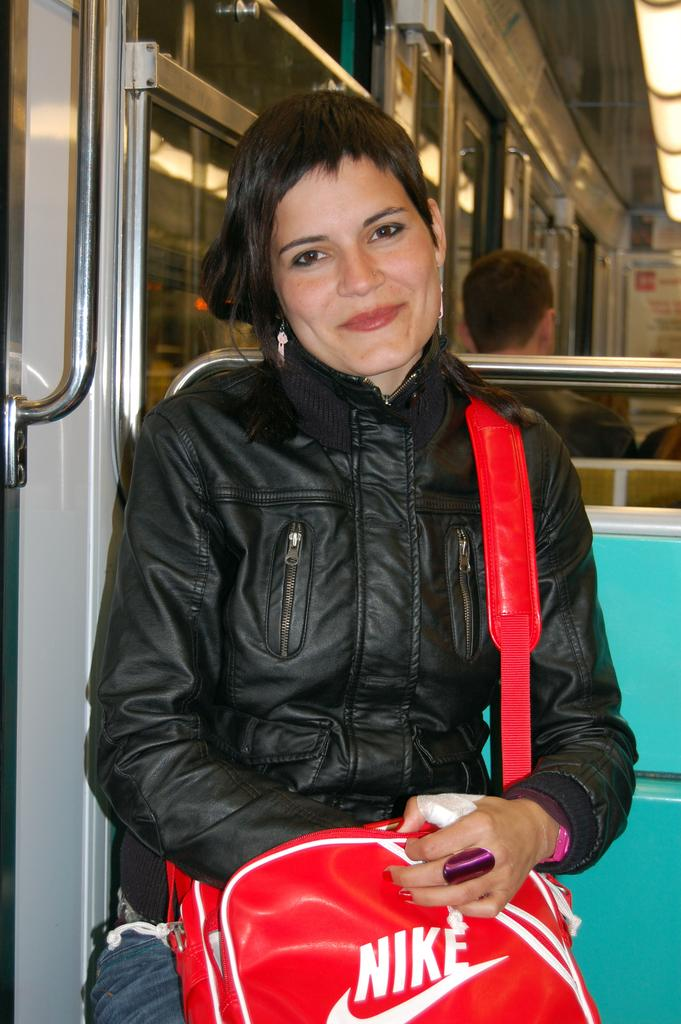<image>
Render a clear and concise summary of the photo. A woman in a black jacket with a red Nike bag 